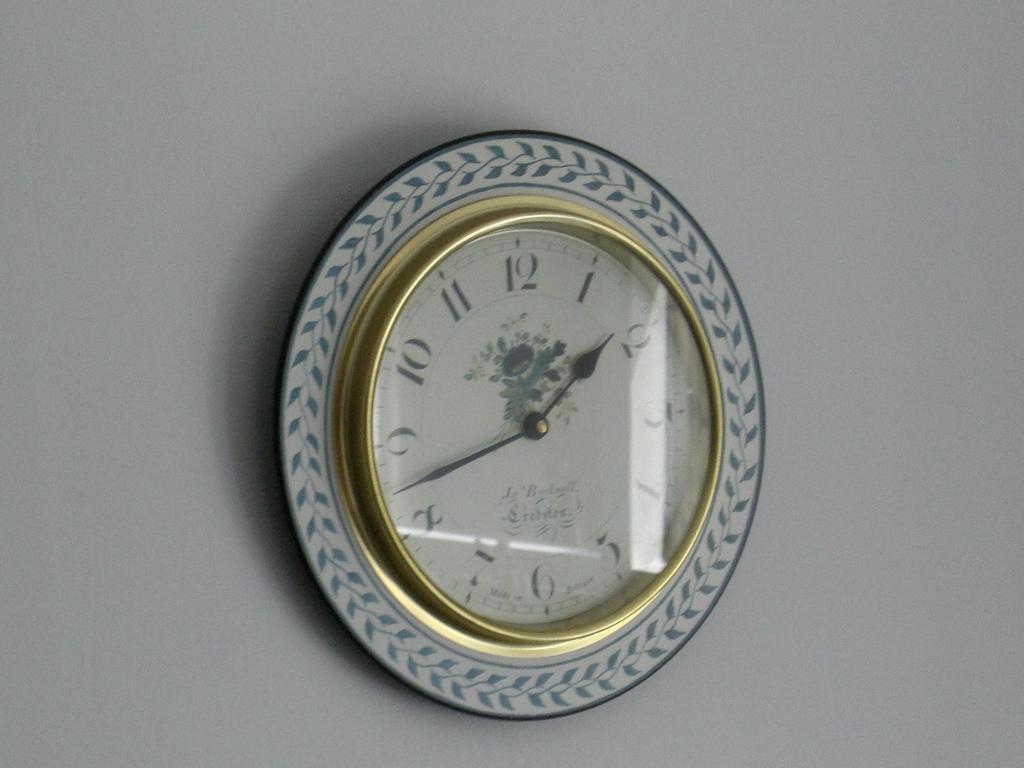Could you give a brief overview of what you see in this image? In the image in the center there is a wall and wall clock. 